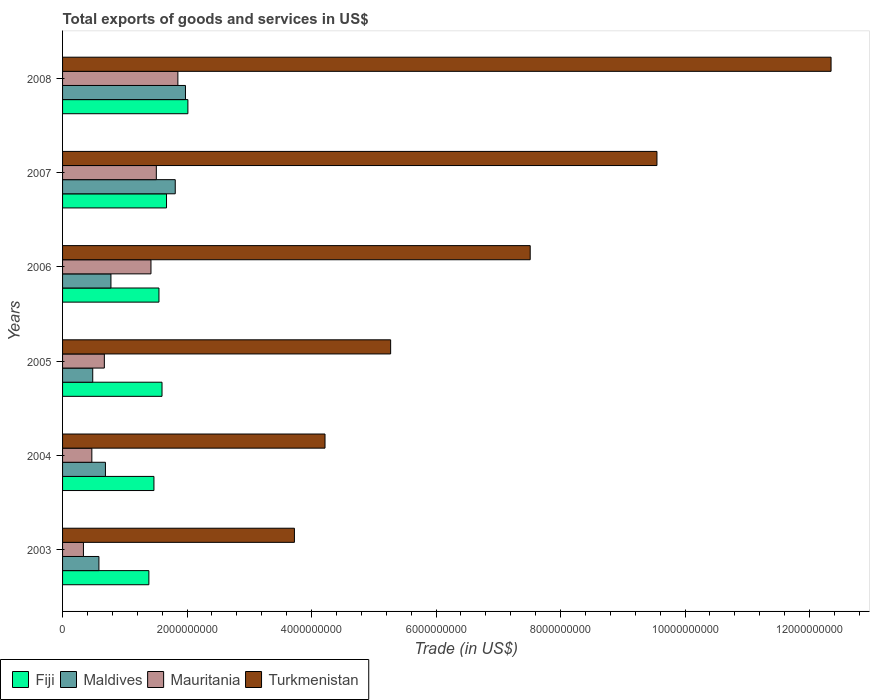Are the number of bars on each tick of the Y-axis equal?
Offer a very short reply. Yes. How many bars are there on the 5th tick from the bottom?
Your answer should be compact. 4. What is the label of the 5th group of bars from the top?
Your answer should be very brief. 2004. What is the total exports of goods and services in Maldives in 2005?
Provide a succinct answer. 4.85e+08. Across all years, what is the maximum total exports of goods and services in Maldives?
Your response must be concise. 1.97e+09. Across all years, what is the minimum total exports of goods and services in Turkmenistan?
Provide a succinct answer. 3.72e+09. What is the total total exports of goods and services in Maldives in the graph?
Offer a terse response. 6.32e+09. What is the difference between the total exports of goods and services in Maldives in 2005 and that in 2008?
Ensure brevity in your answer.  -1.49e+09. What is the difference between the total exports of goods and services in Fiji in 2006 and the total exports of goods and services in Mauritania in 2005?
Offer a very short reply. 8.77e+08. What is the average total exports of goods and services in Fiji per year?
Provide a short and direct response. 1.61e+09. In the year 2004, what is the difference between the total exports of goods and services in Turkmenistan and total exports of goods and services in Mauritania?
Keep it short and to the point. 3.75e+09. In how many years, is the total exports of goods and services in Mauritania greater than 2000000000 US$?
Your answer should be compact. 0. What is the ratio of the total exports of goods and services in Mauritania in 2005 to that in 2007?
Keep it short and to the point. 0.45. Is the total exports of goods and services in Turkmenistan in 2003 less than that in 2004?
Provide a short and direct response. Yes. What is the difference between the highest and the second highest total exports of goods and services in Turkmenistan?
Your response must be concise. 2.80e+09. What is the difference between the highest and the lowest total exports of goods and services in Turkmenistan?
Offer a very short reply. 8.62e+09. In how many years, is the total exports of goods and services in Turkmenistan greater than the average total exports of goods and services in Turkmenistan taken over all years?
Offer a very short reply. 3. What does the 3rd bar from the top in 2006 represents?
Offer a very short reply. Maldives. What does the 1st bar from the bottom in 2004 represents?
Offer a terse response. Fiji. How many bars are there?
Make the answer very short. 24. What is the difference between two consecutive major ticks on the X-axis?
Your answer should be compact. 2.00e+09. Are the values on the major ticks of X-axis written in scientific E-notation?
Offer a terse response. No. Does the graph contain any zero values?
Offer a very short reply. No. Does the graph contain grids?
Offer a terse response. No. Where does the legend appear in the graph?
Your answer should be very brief. Bottom left. How many legend labels are there?
Your answer should be very brief. 4. How are the legend labels stacked?
Ensure brevity in your answer.  Horizontal. What is the title of the graph?
Ensure brevity in your answer.  Total exports of goods and services in US$. What is the label or title of the X-axis?
Your response must be concise. Trade (in US$). What is the Trade (in US$) in Fiji in 2003?
Make the answer very short. 1.39e+09. What is the Trade (in US$) of Maldives in 2003?
Your answer should be very brief. 5.84e+08. What is the Trade (in US$) in Mauritania in 2003?
Offer a terse response. 3.35e+08. What is the Trade (in US$) in Turkmenistan in 2003?
Offer a terse response. 3.72e+09. What is the Trade (in US$) in Fiji in 2004?
Your answer should be very brief. 1.47e+09. What is the Trade (in US$) of Maldives in 2004?
Provide a succinct answer. 6.89e+08. What is the Trade (in US$) in Mauritania in 2004?
Ensure brevity in your answer.  4.70e+08. What is the Trade (in US$) in Turkmenistan in 2004?
Provide a short and direct response. 4.22e+09. What is the Trade (in US$) of Fiji in 2005?
Your answer should be compact. 1.60e+09. What is the Trade (in US$) in Maldives in 2005?
Offer a terse response. 4.85e+08. What is the Trade (in US$) in Mauritania in 2005?
Offer a very short reply. 6.71e+08. What is the Trade (in US$) in Turkmenistan in 2005?
Your response must be concise. 5.27e+09. What is the Trade (in US$) of Fiji in 2006?
Make the answer very short. 1.55e+09. What is the Trade (in US$) of Maldives in 2006?
Offer a very short reply. 7.77e+08. What is the Trade (in US$) in Mauritania in 2006?
Keep it short and to the point. 1.42e+09. What is the Trade (in US$) in Turkmenistan in 2006?
Your response must be concise. 7.51e+09. What is the Trade (in US$) in Fiji in 2007?
Provide a short and direct response. 1.67e+09. What is the Trade (in US$) in Maldives in 2007?
Keep it short and to the point. 1.81e+09. What is the Trade (in US$) in Mauritania in 2007?
Ensure brevity in your answer.  1.51e+09. What is the Trade (in US$) of Turkmenistan in 2007?
Your answer should be compact. 9.55e+09. What is the Trade (in US$) in Fiji in 2008?
Your response must be concise. 2.01e+09. What is the Trade (in US$) of Maldives in 2008?
Keep it short and to the point. 1.97e+09. What is the Trade (in US$) of Mauritania in 2008?
Give a very brief answer. 1.85e+09. What is the Trade (in US$) in Turkmenistan in 2008?
Ensure brevity in your answer.  1.23e+1. Across all years, what is the maximum Trade (in US$) in Fiji?
Provide a succinct answer. 2.01e+09. Across all years, what is the maximum Trade (in US$) of Maldives?
Ensure brevity in your answer.  1.97e+09. Across all years, what is the maximum Trade (in US$) in Mauritania?
Keep it short and to the point. 1.85e+09. Across all years, what is the maximum Trade (in US$) in Turkmenistan?
Offer a very short reply. 1.23e+1. Across all years, what is the minimum Trade (in US$) in Fiji?
Offer a terse response. 1.39e+09. Across all years, what is the minimum Trade (in US$) of Maldives?
Provide a succinct answer. 4.85e+08. Across all years, what is the minimum Trade (in US$) in Mauritania?
Keep it short and to the point. 3.35e+08. Across all years, what is the minimum Trade (in US$) of Turkmenistan?
Provide a succinct answer. 3.72e+09. What is the total Trade (in US$) in Fiji in the graph?
Keep it short and to the point. 9.68e+09. What is the total Trade (in US$) in Maldives in the graph?
Offer a very short reply. 6.32e+09. What is the total Trade (in US$) of Mauritania in the graph?
Offer a very short reply. 6.26e+09. What is the total Trade (in US$) of Turkmenistan in the graph?
Give a very brief answer. 4.26e+1. What is the difference between the Trade (in US$) in Fiji in 2003 and that in 2004?
Your response must be concise. -8.13e+07. What is the difference between the Trade (in US$) in Maldives in 2003 and that in 2004?
Keep it short and to the point. -1.05e+08. What is the difference between the Trade (in US$) of Mauritania in 2003 and that in 2004?
Give a very brief answer. -1.35e+08. What is the difference between the Trade (in US$) of Turkmenistan in 2003 and that in 2004?
Provide a short and direct response. -4.92e+08. What is the difference between the Trade (in US$) of Fiji in 2003 and that in 2005?
Your answer should be compact. -2.11e+08. What is the difference between the Trade (in US$) of Maldives in 2003 and that in 2005?
Your response must be concise. 9.94e+07. What is the difference between the Trade (in US$) in Mauritania in 2003 and that in 2005?
Give a very brief answer. -3.36e+08. What is the difference between the Trade (in US$) of Turkmenistan in 2003 and that in 2005?
Ensure brevity in your answer.  -1.55e+09. What is the difference between the Trade (in US$) of Fiji in 2003 and that in 2006?
Offer a terse response. -1.62e+08. What is the difference between the Trade (in US$) of Maldives in 2003 and that in 2006?
Provide a short and direct response. -1.93e+08. What is the difference between the Trade (in US$) of Mauritania in 2003 and that in 2006?
Ensure brevity in your answer.  -1.08e+09. What is the difference between the Trade (in US$) in Turkmenistan in 2003 and that in 2006?
Keep it short and to the point. -3.79e+09. What is the difference between the Trade (in US$) of Fiji in 2003 and that in 2007?
Offer a very short reply. -2.83e+08. What is the difference between the Trade (in US$) of Maldives in 2003 and that in 2007?
Keep it short and to the point. -1.23e+09. What is the difference between the Trade (in US$) in Mauritania in 2003 and that in 2007?
Offer a very short reply. -1.17e+09. What is the difference between the Trade (in US$) in Turkmenistan in 2003 and that in 2007?
Keep it short and to the point. -5.82e+09. What is the difference between the Trade (in US$) in Fiji in 2003 and that in 2008?
Provide a succinct answer. -6.27e+08. What is the difference between the Trade (in US$) of Maldives in 2003 and that in 2008?
Your answer should be very brief. -1.39e+09. What is the difference between the Trade (in US$) of Mauritania in 2003 and that in 2008?
Provide a succinct answer. -1.52e+09. What is the difference between the Trade (in US$) of Turkmenistan in 2003 and that in 2008?
Provide a short and direct response. -8.62e+09. What is the difference between the Trade (in US$) in Fiji in 2004 and that in 2005?
Provide a succinct answer. -1.30e+08. What is the difference between the Trade (in US$) in Maldives in 2004 and that in 2005?
Give a very brief answer. 2.04e+08. What is the difference between the Trade (in US$) of Mauritania in 2004 and that in 2005?
Your answer should be very brief. -2.01e+08. What is the difference between the Trade (in US$) of Turkmenistan in 2004 and that in 2005?
Keep it short and to the point. -1.05e+09. What is the difference between the Trade (in US$) in Fiji in 2004 and that in 2006?
Offer a terse response. -8.06e+07. What is the difference between the Trade (in US$) of Maldives in 2004 and that in 2006?
Offer a very short reply. -8.85e+07. What is the difference between the Trade (in US$) in Mauritania in 2004 and that in 2006?
Give a very brief answer. -9.50e+08. What is the difference between the Trade (in US$) of Turkmenistan in 2004 and that in 2006?
Give a very brief answer. -3.30e+09. What is the difference between the Trade (in US$) in Fiji in 2004 and that in 2007?
Provide a short and direct response. -2.02e+08. What is the difference between the Trade (in US$) of Maldives in 2004 and that in 2007?
Your answer should be compact. -1.12e+09. What is the difference between the Trade (in US$) in Mauritania in 2004 and that in 2007?
Make the answer very short. -1.04e+09. What is the difference between the Trade (in US$) of Turkmenistan in 2004 and that in 2007?
Provide a short and direct response. -5.33e+09. What is the difference between the Trade (in US$) in Fiji in 2004 and that in 2008?
Make the answer very short. -5.45e+08. What is the difference between the Trade (in US$) in Maldives in 2004 and that in 2008?
Keep it short and to the point. -1.29e+09. What is the difference between the Trade (in US$) in Mauritania in 2004 and that in 2008?
Your answer should be very brief. -1.38e+09. What is the difference between the Trade (in US$) in Turkmenistan in 2004 and that in 2008?
Your answer should be very brief. -8.13e+09. What is the difference between the Trade (in US$) in Fiji in 2005 and that in 2006?
Give a very brief answer. 4.91e+07. What is the difference between the Trade (in US$) in Maldives in 2005 and that in 2006?
Make the answer very short. -2.93e+08. What is the difference between the Trade (in US$) of Mauritania in 2005 and that in 2006?
Give a very brief answer. -7.49e+08. What is the difference between the Trade (in US$) in Turkmenistan in 2005 and that in 2006?
Keep it short and to the point. -2.24e+09. What is the difference between the Trade (in US$) in Fiji in 2005 and that in 2007?
Your answer should be compact. -7.23e+07. What is the difference between the Trade (in US$) in Maldives in 2005 and that in 2007?
Your answer should be compact. -1.33e+09. What is the difference between the Trade (in US$) in Mauritania in 2005 and that in 2007?
Keep it short and to the point. -8.35e+08. What is the difference between the Trade (in US$) in Turkmenistan in 2005 and that in 2007?
Ensure brevity in your answer.  -4.28e+09. What is the difference between the Trade (in US$) in Fiji in 2005 and that in 2008?
Provide a short and direct response. -4.16e+08. What is the difference between the Trade (in US$) in Maldives in 2005 and that in 2008?
Make the answer very short. -1.49e+09. What is the difference between the Trade (in US$) in Mauritania in 2005 and that in 2008?
Your answer should be very brief. -1.18e+09. What is the difference between the Trade (in US$) in Turkmenistan in 2005 and that in 2008?
Provide a succinct answer. -7.08e+09. What is the difference between the Trade (in US$) of Fiji in 2006 and that in 2007?
Ensure brevity in your answer.  -1.21e+08. What is the difference between the Trade (in US$) of Maldives in 2006 and that in 2007?
Offer a terse response. -1.03e+09. What is the difference between the Trade (in US$) in Mauritania in 2006 and that in 2007?
Keep it short and to the point. -8.63e+07. What is the difference between the Trade (in US$) in Turkmenistan in 2006 and that in 2007?
Your response must be concise. -2.04e+09. What is the difference between the Trade (in US$) of Fiji in 2006 and that in 2008?
Make the answer very short. -4.65e+08. What is the difference between the Trade (in US$) in Maldives in 2006 and that in 2008?
Keep it short and to the point. -1.20e+09. What is the difference between the Trade (in US$) of Mauritania in 2006 and that in 2008?
Provide a short and direct response. -4.32e+08. What is the difference between the Trade (in US$) of Turkmenistan in 2006 and that in 2008?
Ensure brevity in your answer.  -4.83e+09. What is the difference between the Trade (in US$) in Fiji in 2007 and that in 2008?
Give a very brief answer. -3.43e+08. What is the difference between the Trade (in US$) of Maldives in 2007 and that in 2008?
Keep it short and to the point. -1.64e+08. What is the difference between the Trade (in US$) of Mauritania in 2007 and that in 2008?
Your response must be concise. -3.46e+08. What is the difference between the Trade (in US$) of Turkmenistan in 2007 and that in 2008?
Offer a very short reply. -2.80e+09. What is the difference between the Trade (in US$) of Fiji in 2003 and the Trade (in US$) of Maldives in 2004?
Your answer should be compact. 6.98e+08. What is the difference between the Trade (in US$) of Fiji in 2003 and the Trade (in US$) of Mauritania in 2004?
Provide a succinct answer. 9.16e+08. What is the difference between the Trade (in US$) in Fiji in 2003 and the Trade (in US$) in Turkmenistan in 2004?
Offer a very short reply. -2.83e+09. What is the difference between the Trade (in US$) of Maldives in 2003 and the Trade (in US$) of Mauritania in 2004?
Your response must be concise. 1.14e+08. What is the difference between the Trade (in US$) of Maldives in 2003 and the Trade (in US$) of Turkmenistan in 2004?
Ensure brevity in your answer.  -3.63e+09. What is the difference between the Trade (in US$) in Mauritania in 2003 and the Trade (in US$) in Turkmenistan in 2004?
Keep it short and to the point. -3.88e+09. What is the difference between the Trade (in US$) of Fiji in 2003 and the Trade (in US$) of Maldives in 2005?
Provide a succinct answer. 9.02e+08. What is the difference between the Trade (in US$) in Fiji in 2003 and the Trade (in US$) in Mauritania in 2005?
Your answer should be very brief. 7.15e+08. What is the difference between the Trade (in US$) of Fiji in 2003 and the Trade (in US$) of Turkmenistan in 2005?
Give a very brief answer. -3.88e+09. What is the difference between the Trade (in US$) in Maldives in 2003 and the Trade (in US$) in Mauritania in 2005?
Provide a short and direct response. -8.72e+07. What is the difference between the Trade (in US$) of Maldives in 2003 and the Trade (in US$) of Turkmenistan in 2005?
Offer a terse response. -4.69e+09. What is the difference between the Trade (in US$) of Mauritania in 2003 and the Trade (in US$) of Turkmenistan in 2005?
Keep it short and to the point. -4.93e+09. What is the difference between the Trade (in US$) of Fiji in 2003 and the Trade (in US$) of Maldives in 2006?
Give a very brief answer. 6.09e+08. What is the difference between the Trade (in US$) in Fiji in 2003 and the Trade (in US$) in Mauritania in 2006?
Make the answer very short. -3.35e+07. What is the difference between the Trade (in US$) in Fiji in 2003 and the Trade (in US$) in Turkmenistan in 2006?
Offer a terse response. -6.13e+09. What is the difference between the Trade (in US$) of Maldives in 2003 and the Trade (in US$) of Mauritania in 2006?
Keep it short and to the point. -8.36e+08. What is the difference between the Trade (in US$) in Maldives in 2003 and the Trade (in US$) in Turkmenistan in 2006?
Keep it short and to the point. -6.93e+09. What is the difference between the Trade (in US$) in Mauritania in 2003 and the Trade (in US$) in Turkmenistan in 2006?
Provide a succinct answer. -7.18e+09. What is the difference between the Trade (in US$) of Fiji in 2003 and the Trade (in US$) of Maldives in 2007?
Provide a succinct answer. -4.24e+08. What is the difference between the Trade (in US$) of Fiji in 2003 and the Trade (in US$) of Mauritania in 2007?
Your answer should be compact. -1.20e+08. What is the difference between the Trade (in US$) in Fiji in 2003 and the Trade (in US$) in Turkmenistan in 2007?
Offer a terse response. -8.16e+09. What is the difference between the Trade (in US$) in Maldives in 2003 and the Trade (in US$) in Mauritania in 2007?
Your answer should be very brief. -9.22e+08. What is the difference between the Trade (in US$) in Maldives in 2003 and the Trade (in US$) in Turkmenistan in 2007?
Ensure brevity in your answer.  -8.96e+09. What is the difference between the Trade (in US$) in Mauritania in 2003 and the Trade (in US$) in Turkmenistan in 2007?
Make the answer very short. -9.21e+09. What is the difference between the Trade (in US$) in Fiji in 2003 and the Trade (in US$) in Maldives in 2008?
Provide a succinct answer. -5.88e+08. What is the difference between the Trade (in US$) in Fiji in 2003 and the Trade (in US$) in Mauritania in 2008?
Give a very brief answer. -4.66e+08. What is the difference between the Trade (in US$) of Fiji in 2003 and the Trade (in US$) of Turkmenistan in 2008?
Make the answer very short. -1.10e+1. What is the difference between the Trade (in US$) in Maldives in 2003 and the Trade (in US$) in Mauritania in 2008?
Provide a succinct answer. -1.27e+09. What is the difference between the Trade (in US$) of Maldives in 2003 and the Trade (in US$) of Turkmenistan in 2008?
Your response must be concise. -1.18e+1. What is the difference between the Trade (in US$) of Mauritania in 2003 and the Trade (in US$) of Turkmenistan in 2008?
Your answer should be compact. -1.20e+1. What is the difference between the Trade (in US$) of Fiji in 2004 and the Trade (in US$) of Maldives in 2005?
Provide a succinct answer. 9.83e+08. What is the difference between the Trade (in US$) of Fiji in 2004 and the Trade (in US$) of Mauritania in 2005?
Provide a short and direct response. 7.97e+08. What is the difference between the Trade (in US$) of Fiji in 2004 and the Trade (in US$) of Turkmenistan in 2005?
Ensure brevity in your answer.  -3.80e+09. What is the difference between the Trade (in US$) of Maldives in 2004 and the Trade (in US$) of Mauritania in 2005?
Your answer should be compact. 1.74e+07. What is the difference between the Trade (in US$) in Maldives in 2004 and the Trade (in US$) in Turkmenistan in 2005?
Keep it short and to the point. -4.58e+09. What is the difference between the Trade (in US$) of Mauritania in 2004 and the Trade (in US$) of Turkmenistan in 2005?
Make the answer very short. -4.80e+09. What is the difference between the Trade (in US$) of Fiji in 2004 and the Trade (in US$) of Maldives in 2006?
Your answer should be very brief. 6.91e+08. What is the difference between the Trade (in US$) of Fiji in 2004 and the Trade (in US$) of Mauritania in 2006?
Ensure brevity in your answer.  4.78e+07. What is the difference between the Trade (in US$) in Fiji in 2004 and the Trade (in US$) in Turkmenistan in 2006?
Provide a succinct answer. -6.04e+09. What is the difference between the Trade (in US$) of Maldives in 2004 and the Trade (in US$) of Mauritania in 2006?
Keep it short and to the point. -7.31e+08. What is the difference between the Trade (in US$) in Maldives in 2004 and the Trade (in US$) in Turkmenistan in 2006?
Offer a terse response. -6.82e+09. What is the difference between the Trade (in US$) of Mauritania in 2004 and the Trade (in US$) of Turkmenistan in 2006?
Your response must be concise. -7.04e+09. What is the difference between the Trade (in US$) of Fiji in 2004 and the Trade (in US$) of Maldives in 2007?
Offer a terse response. -3.42e+08. What is the difference between the Trade (in US$) of Fiji in 2004 and the Trade (in US$) of Mauritania in 2007?
Offer a very short reply. -3.85e+07. What is the difference between the Trade (in US$) in Fiji in 2004 and the Trade (in US$) in Turkmenistan in 2007?
Provide a short and direct response. -8.08e+09. What is the difference between the Trade (in US$) of Maldives in 2004 and the Trade (in US$) of Mauritania in 2007?
Ensure brevity in your answer.  -8.18e+08. What is the difference between the Trade (in US$) of Maldives in 2004 and the Trade (in US$) of Turkmenistan in 2007?
Keep it short and to the point. -8.86e+09. What is the difference between the Trade (in US$) in Mauritania in 2004 and the Trade (in US$) in Turkmenistan in 2007?
Provide a succinct answer. -9.08e+09. What is the difference between the Trade (in US$) of Fiji in 2004 and the Trade (in US$) of Maldives in 2008?
Give a very brief answer. -5.06e+08. What is the difference between the Trade (in US$) in Fiji in 2004 and the Trade (in US$) in Mauritania in 2008?
Your answer should be very brief. -3.84e+08. What is the difference between the Trade (in US$) of Fiji in 2004 and the Trade (in US$) of Turkmenistan in 2008?
Provide a short and direct response. -1.09e+1. What is the difference between the Trade (in US$) in Maldives in 2004 and the Trade (in US$) in Mauritania in 2008?
Give a very brief answer. -1.16e+09. What is the difference between the Trade (in US$) in Maldives in 2004 and the Trade (in US$) in Turkmenistan in 2008?
Provide a succinct answer. -1.17e+1. What is the difference between the Trade (in US$) of Mauritania in 2004 and the Trade (in US$) of Turkmenistan in 2008?
Keep it short and to the point. -1.19e+1. What is the difference between the Trade (in US$) in Fiji in 2005 and the Trade (in US$) in Maldives in 2006?
Your answer should be compact. 8.20e+08. What is the difference between the Trade (in US$) in Fiji in 2005 and the Trade (in US$) in Mauritania in 2006?
Give a very brief answer. 1.77e+08. What is the difference between the Trade (in US$) in Fiji in 2005 and the Trade (in US$) in Turkmenistan in 2006?
Your response must be concise. -5.91e+09. What is the difference between the Trade (in US$) in Maldives in 2005 and the Trade (in US$) in Mauritania in 2006?
Provide a short and direct response. -9.35e+08. What is the difference between the Trade (in US$) of Maldives in 2005 and the Trade (in US$) of Turkmenistan in 2006?
Offer a very short reply. -7.03e+09. What is the difference between the Trade (in US$) of Mauritania in 2005 and the Trade (in US$) of Turkmenistan in 2006?
Your response must be concise. -6.84e+09. What is the difference between the Trade (in US$) of Fiji in 2005 and the Trade (in US$) of Maldives in 2007?
Give a very brief answer. -2.13e+08. What is the difference between the Trade (in US$) of Fiji in 2005 and the Trade (in US$) of Mauritania in 2007?
Make the answer very short. 9.12e+07. What is the difference between the Trade (in US$) of Fiji in 2005 and the Trade (in US$) of Turkmenistan in 2007?
Offer a very short reply. -7.95e+09. What is the difference between the Trade (in US$) in Maldives in 2005 and the Trade (in US$) in Mauritania in 2007?
Provide a succinct answer. -1.02e+09. What is the difference between the Trade (in US$) in Maldives in 2005 and the Trade (in US$) in Turkmenistan in 2007?
Offer a terse response. -9.06e+09. What is the difference between the Trade (in US$) in Mauritania in 2005 and the Trade (in US$) in Turkmenistan in 2007?
Offer a terse response. -8.88e+09. What is the difference between the Trade (in US$) of Fiji in 2005 and the Trade (in US$) of Maldives in 2008?
Offer a very short reply. -3.77e+08. What is the difference between the Trade (in US$) in Fiji in 2005 and the Trade (in US$) in Mauritania in 2008?
Give a very brief answer. -2.55e+08. What is the difference between the Trade (in US$) of Fiji in 2005 and the Trade (in US$) of Turkmenistan in 2008?
Ensure brevity in your answer.  -1.07e+1. What is the difference between the Trade (in US$) in Maldives in 2005 and the Trade (in US$) in Mauritania in 2008?
Offer a very short reply. -1.37e+09. What is the difference between the Trade (in US$) in Maldives in 2005 and the Trade (in US$) in Turkmenistan in 2008?
Provide a succinct answer. -1.19e+1. What is the difference between the Trade (in US$) of Mauritania in 2005 and the Trade (in US$) of Turkmenistan in 2008?
Make the answer very short. -1.17e+1. What is the difference between the Trade (in US$) in Fiji in 2006 and the Trade (in US$) in Maldives in 2007?
Offer a very short reply. -2.62e+08. What is the difference between the Trade (in US$) in Fiji in 2006 and the Trade (in US$) in Mauritania in 2007?
Your answer should be very brief. 4.22e+07. What is the difference between the Trade (in US$) of Fiji in 2006 and the Trade (in US$) of Turkmenistan in 2007?
Your answer should be compact. -8.00e+09. What is the difference between the Trade (in US$) of Maldives in 2006 and the Trade (in US$) of Mauritania in 2007?
Your response must be concise. -7.29e+08. What is the difference between the Trade (in US$) of Maldives in 2006 and the Trade (in US$) of Turkmenistan in 2007?
Your answer should be very brief. -8.77e+09. What is the difference between the Trade (in US$) in Mauritania in 2006 and the Trade (in US$) in Turkmenistan in 2007?
Provide a short and direct response. -8.13e+09. What is the difference between the Trade (in US$) of Fiji in 2006 and the Trade (in US$) of Maldives in 2008?
Your answer should be very brief. -4.26e+08. What is the difference between the Trade (in US$) of Fiji in 2006 and the Trade (in US$) of Mauritania in 2008?
Offer a terse response. -3.04e+08. What is the difference between the Trade (in US$) in Fiji in 2006 and the Trade (in US$) in Turkmenistan in 2008?
Offer a terse response. -1.08e+1. What is the difference between the Trade (in US$) in Maldives in 2006 and the Trade (in US$) in Mauritania in 2008?
Make the answer very short. -1.08e+09. What is the difference between the Trade (in US$) in Maldives in 2006 and the Trade (in US$) in Turkmenistan in 2008?
Provide a succinct answer. -1.16e+1. What is the difference between the Trade (in US$) of Mauritania in 2006 and the Trade (in US$) of Turkmenistan in 2008?
Provide a succinct answer. -1.09e+1. What is the difference between the Trade (in US$) in Fiji in 2007 and the Trade (in US$) in Maldives in 2008?
Provide a short and direct response. -3.04e+08. What is the difference between the Trade (in US$) in Fiji in 2007 and the Trade (in US$) in Mauritania in 2008?
Make the answer very short. -1.82e+08. What is the difference between the Trade (in US$) in Fiji in 2007 and the Trade (in US$) in Turkmenistan in 2008?
Your response must be concise. -1.07e+1. What is the difference between the Trade (in US$) of Maldives in 2007 and the Trade (in US$) of Mauritania in 2008?
Provide a succinct answer. -4.19e+07. What is the difference between the Trade (in US$) of Maldives in 2007 and the Trade (in US$) of Turkmenistan in 2008?
Your answer should be very brief. -1.05e+1. What is the difference between the Trade (in US$) of Mauritania in 2007 and the Trade (in US$) of Turkmenistan in 2008?
Give a very brief answer. -1.08e+1. What is the average Trade (in US$) in Fiji per year?
Give a very brief answer. 1.61e+09. What is the average Trade (in US$) of Maldives per year?
Ensure brevity in your answer.  1.05e+09. What is the average Trade (in US$) in Mauritania per year?
Ensure brevity in your answer.  1.04e+09. What is the average Trade (in US$) in Turkmenistan per year?
Make the answer very short. 7.10e+09. In the year 2003, what is the difference between the Trade (in US$) of Fiji and Trade (in US$) of Maldives?
Your response must be concise. 8.03e+08. In the year 2003, what is the difference between the Trade (in US$) of Fiji and Trade (in US$) of Mauritania?
Provide a succinct answer. 1.05e+09. In the year 2003, what is the difference between the Trade (in US$) in Fiji and Trade (in US$) in Turkmenistan?
Offer a terse response. -2.34e+09. In the year 2003, what is the difference between the Trade (in US$) of Maldives and Trade (in US$) of Mauritania?
Your answer should be compact. 2.49e+08. In the year 2003, what is the difference between the Trade (in US$) in Maldives and Trade (in US$) in Turkmenistan?
Give a very brief answer. -3.14e+09. In the year 2003, what is the difference between the Trade (in US$) in Mauritania and Trade (in US$) in Turkmenistan?
Your answer should be very brief. -3.39e+09. In the year 2004, what is the difference between the Trade (in US$) of Fiji and Trade (in US$) of Maldives?
Ensure brevity in your answer.  7.79e+08. In the year 2004, what is the difference between the Trade (in US$) of Fiji and Trade (in US$) of Mauritania?
Offer a terse response. 9.98e+08. In the year 2004, what is the difference between the Trade (in US$) in Fiji and Trade (in US$) in Turkmenistan?
Keep it short and to the point. -2.75e+09. In the year 2004, what is the difference between the Trade (in US$) in Maldives and Trade (in US$) in Mauritania?
Make the answer very short. 2.18e+08. In the year 2004, what is the difference between the Trade (in US$) of Maldives and Trade (in US$) of Turkmenistan?
Your response must be concise. -3.53e+09. In the year 2004, what is the difference between the Trade (in US$) of Mauritania and Trade (in US$) of Turkmenistan?
Your answer should be very brief. -3.75e+09. In the year 2005, what is the difference between the Trade (in US$) of Fiji and Trade (in US$) of Maldives?
Provide a short and direct response. 1.11e+09. In the year 2005, what is the difference between the Trade (in US$) of Fiji and Trade (in US$) of Mauritania?
Provide a short and direct response. 9.26e+08. In the year 2005, what is the difference between the Trade (in US$) in Fiji and Trade (in US$) in Turkmenistan?
Provide a short and direct response. -3.67e+09. In the year 2005, what is the difference between the Trade (in US$) in Maldives and Trade (in US$) in Mauritania?
Make the answer very short. -1.87e+08. In the year 2005, what is the difference between the Trade (in US$) in Maldives and Trade (in US$) in Turkmenistan?
Keep it short and to the point. -4.79e+09. In the year 2005, what is the difference between the Trade (in US$) in Mauritania and Trade (in US$) in Turkmenistan?
Offer a terse response. -4.60e+09. In the year 2006, what is the difference between the Trade (in US$) in Fiji and Trade (in US$) in Maldives?
Provide a short and direct response. 7.71e+08. In the year 2006, what is the difference between the Trade (in US$) of Fiji and Trade (in US$) of Mauritania?
Provide a short and direct response. 1.28e+08. In the year 2006, what is the difference between the Trade (in US$) of Fiji and Trade (in US$) of Turkmenistan?
Give a very brief answer. -5.96e+09. In the year 2006, what is the difference between the Trade (in US$) of Maldives and Trade (in US$) of Mauritania?
Give a very brief answer. -6.43e+08. In the year 2006, what is the difference between the Trade (in US$) of Maldives and Trade (in US$) of Turkmenistan?
Provide a succinct answer. -6.73e+09. In the year 2006, what is the difference between the Trade (in US$) in Mauritania and Trade (in US$) in Turkmenistan?
Your answer should be compact. -6.09e+09. In the year 2007, what is the difference between the Trade (in US$) of Fiji and Trade (in US$) of Maldives?
Your response must be concise. -1.40e+08. In the year 2007, what is the difference between the Trade (in US$) of Fiji and Trade (in US$) of Mauritania?
Offer a very short reply. 1.64e+08. In the year 2007, what is the difference between the Trade (in US$) in Fiji and Trade (in US$) in Turkmenistan?
Offer a terse response. -7.88e+09. In the year 2007, what is the difference between the Trade (in US$) in Maldives and Trade (in US$) in Mauritania?
Your answer should be compact. 3.04e+08. In the year 2007, what is the difference between the Trade (in US$) in Maldives and Trade (in US$) in Turkmenistan?
Your answer should be compact. -7.74e+09. In the year 2007, what is the difference between the Trade (in US$) in Mauritania and Trade (in US$) in Turkmenistan?
Keep it short and to the point. -8.04e+09. In the year 2008, what is the difference between the Trade (in US$) in Fiji and Trade (in US$) in Maldives?
Your response must be concise. 3.89e+07. In the year 2008, what is the difference between the Trade (in US$) of Fiji and Trade (in US$) of Mauritania?
Offer a very short reply. 1.61e+08. In the year 2008, what is the difference between the Trade (in US$) in Fiji and Trade (in US$) in Turkmenistan?
Keep it short and to the point. -1.03e+1. In the year 2008, what is the difference between the Trade (in US$) of Maldives and Trade (in US$) of Mauritania?
Give a very brief answer. 1.22e+08. In the year 2008, what is the difference between the Trade (in US$) in Maldives and Trade (in US$) in Turkmenistan?
Your answer should be very brief. -1.04e+1. In the year 2008, what is the difference between the Trade (in US$) in Mauritania and Trade (in US$) in Turkmenistan?
Offer a terse response. -1.05e+1. What is the ratio of the Trade (in US$) of Fiji in 2003 to that in 2004?
Ensure brevity in your answer.  0.94. What is the ratio of the Trade (in US$) of Maldives in 2003 to that in 2004?
Provide a short and direct response. 0.85. What is the ratio of the Trade (in US$) of Mauritania in 2003 to that in 2004?
Give a very brief answer. 0.71. What is the ratio of the Trade (in US$) of Turkmenistan in 2003 to that in 2004?
Provide a short and direct response. 0.88. What is the ratio of the Trade (in US$) in Fiji in 2003 to that in 2005?
Offer a terse response. 0.87. What is the ratio of the Trade (in US$) in Maldives in 2003 to that in 2005?
Provide a succinct answer. 1.21. What is the ratio of the Trade (in US$) in Mauritania in 2003 to that in 2005?
Provide a short and direct response. 0.5. What is the ratio of the Trade (in US$) in Turkmenistan in 2003 to that in 2005?
Provide a short and direct response. 0.71. What is the ratio of the Trade (in US$) in Fiji in 2003 to that in 2006?
Keep it short and to the point. 0.9. What is the ratio of the Trade (in US$) of Maldives in 2003 to that in 2006?
Provide a short and direct response. 0.75. What is the ratio of the Trade (in US$) of Mauritania in 2003 to that in 2006?
Ensure brevity in your answer.  0.24. What is the ratio of the Trade (in US$) of Turkmenistan in 2003 to that in 2006?
Your answer should be very brief. 0.5. What is the ratio of the Trade (in US$) of Fiji in 2003 to that in 2007?
Your answer should be compact. 0.83. What is the ratio of the Trade (in US$) of Maldives in 2003 to that in 2007?
Provide a succinct answer. 0.32. What is the ratio of the Trade (in US$) in Mauritania in 2003 to that in 2007?
Provide a short and direct response. 0.22. What is the ratio of the Trade (in US$) of Turkmenistan in 2003 to that in 2007?
Keep it short and to the point. 0.39. What is the ratio of the Trade (in US$) in Fiji in 2003 to that in 2008?
Your answer should be compact. 0.69. What is the ratio of the Trade (in US$) of Maldives in 2003 to that in 2008?
Your answer should be compact. 0.3. What is the ratio of the Trade (in US$) in Mauritania in 2003 to that in 2008?
Provide a succinct answer. 0.18. What is the ratio of the Trade (in US$) of Turkmenistan in 2003 to that in 2008?
Offer a very short reply. 0.3. What is the ratio of the Trade (in US$) of Fiji in 2004 to that in 2005?
Make the answer very short. 0.92. What is the ratio of the Trade (in US$) in Maldives in 2004 to that in 2005?
Offer a terse response. 1.42. What is the ratio of the Trade (in US$) of Mauritania in 2004 to that in 2005?
Offer a terse response. 0.7. What is the ratio of the Trade (in US$) in Fiji in 2004 to that in 2006?
Offer a very short reply. 0.95. What is the ratio of the Trade (in US$) of Maldives in 2004 to that in 2006?
Offer a terse response. 0.89. What is the ratio of the Trade (in US$) of Mauritania in 2004 to that in 2006?
Make the answer very short. 0.33. What is the ratio of the Trade (in US$) of Turkmenistan in 2004 to that in 2006?
Provide a short and direct response. 0.56. What is the ratio of the Trade (in US$) of Fiji in 2004 to that in 2007?
Make the answer very short. 0.88. What is the ratio of the Trade (in US$) of Maldives in 2004 to that in 2007?
Make the answer very short. 0.38. What is the ratio of the Trade (in US$) of Mauritania in 2004 to that in 2007?
Provide a succinct answer. 0.31. What is the ratio of the Trade (in US$) in Turkmenistan in 2004 to that in 2007?
Make the answer very short. 0.44. What is the ratio of the Trade (in US$) in Fiji in 2004 to that in 2008?
Your response must be concise. 0.73. What is the ratio of the Trade (in US$) of Maldives in 2004 to that in 2008?
Your answer should be compact. 0.35. What is the ratio of the Trade (in US$) of Mauritania in 2004 to that in 2008?
Your answer should be compact. 0.25. What is the ratio of the Trade (in US$) of Turkmenistan in 2004 to that in 2008?
Keep it short and to the point. 0.34. What is the ratio of the Trade (in US$) of Fiji in 2005 to that in 2006?
Provide a short and direct response. 1.03. What is the ratio of the Trade (in US$) of Maldives in 2005 to that in 2006?
Provide a short and direct response. 0.62. What is the ratio of the Trade (in US$) of Mauritania in 2005 to that in 2006?
Keep it short and to the point. 0.47. What is the ratio of the Trade (in US$) of Turkmenistan in 2005 to that in 2006?
Keep it short and to the point. 0.7. What is the ratio of the Trade (in US$) in Fiji in 2005 to that in 2007?
Keep it short and to the point. 0.96. What is the ratio of the Trade (in US$) in Maldives in 2005 to that in 2007?
Provide a short and direct response. 0.27. What is the ratio of the Trade (in US$) of Mauritania in 2005 to that in 2007?
Make the answer very short. 0.45. What is the ratio of the Trade (in US$) of Turkmenistan in 2005 to that in 2007?
Provide a succinct answer. 0.55. What is the ratio of the Trade (in US$) of Fiji in 2005 to that in 2008?
Provide a succinct answer. 0.79. What is the ratio of the Trade (in US$) in Maldives in 2005 to that in 2008?
Offer a terse response. 0.25. What is the ratio of the Trade (in US$) of Mauritania in 2005 to that in 2008?
Provide a short and direct response. 0.36. What is the ratio of the Trade (in US$) in Turkmenistan in 2005 to that in 2008?
Keep it short and to the point. 0.43. What is the ratio of the Trade (in US$) in Fiji in 2006 to that in 2007?
Provide a short and direct response. 0.93. What is the ratio of the Trade (in US$) in Maldives in 2006 to that in 2007?
Your answer should be compact. 0.43. What is the ratio of the Trade (in US$) in Mauritania in 2006 to that in 2007?
Make the answer very short. 0.94. What is the ratio of the Trade (in US$) in Turkmenistan in 2006 to that in 2007?
Your response must be concise. 0.79. What is the ratio of the Trade (in US$) of Fiji in 2006 to that in 2008?
Your response must be concise. 0.77. What is the ratio of the Trade (in US$) in Maldives in 2006 to that in 2008?
Your answer should be very brief. 0.39. What is the ratio of the Trade (in US$) of Mauritania in 2006 to that in 2008?
Offer a very short reply. 0.77. What is the ratio of the Trade (in US$) of Turkmenistan in 2006 to that in 2008?
Keep it short and to the point. 0.61. What is the ratio of the Trade (in US$) in Fiji in 2007 to that in 2008?
Your answer should be compact. 0.83. What is the ratio of the Trade (in US$) of Maldives in 2007 to that in 2008?
Your answer should be compact. 0.92. What is the ratio of the Trade (in US$) of Mauritania in 2007 to that in 2008?
Offer a very short reply. 0.81. What is the ratio of the Trade (in US$) of Turkmenistan in 2007 to that in 2008?
Provide a succinct answer. 0.77. What is the difference between the highest and the second highest Trade (in US$) of Fiji?
Keep it short and to the point. 3.43e+08. What is the difference between the highest and the second highest Trade (in US$) in Maldives?
Provide a short and direct response. 1.64e+08. What is the difference between the highest and the second highest Trade (in US$) in Mauritania?
Provide a short and direct response. 3.46e+08. What is the difference between the highest and the second highest Trade (in US$) of Turkmenistan?
Give a very brief answer. 2.80e+09. What is the difference between the highest and the lowest Trade (in US$) in Fiji?
Keep it short and to the point. 6.27e+08. What is the difference between the highest and the lowest Trade (in US$) in Maldives?
Ensure brevity in your answer.  1.49e+09. What is the difference between the highest and the lowest Trade (in US$) in Mauritania?
Keep it short and to the point. 1.52e+09. What is the difference between the highest and the lowest Trade (in US$) of Turkmenistan?
Offer a terse response. 8.62e+09. 